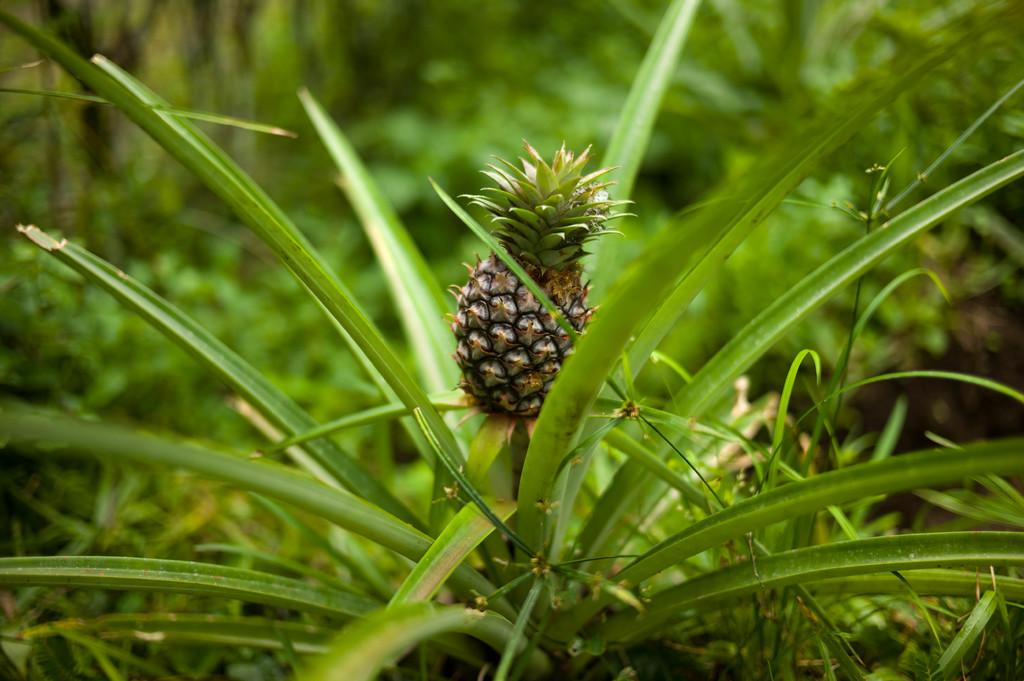What type of fruit is in the image? There is a pineapple in the image. Where is the pineapple located? The pineapple is in a plant. What can be seen on the right side of the image? There are many leaves visible on the right side of the image. What type of engine is visible in the image? There is no engine present in the image. What advice can be given to the pineapple in the image? The pineapple is a fruit and cannot receive or follow advice. 